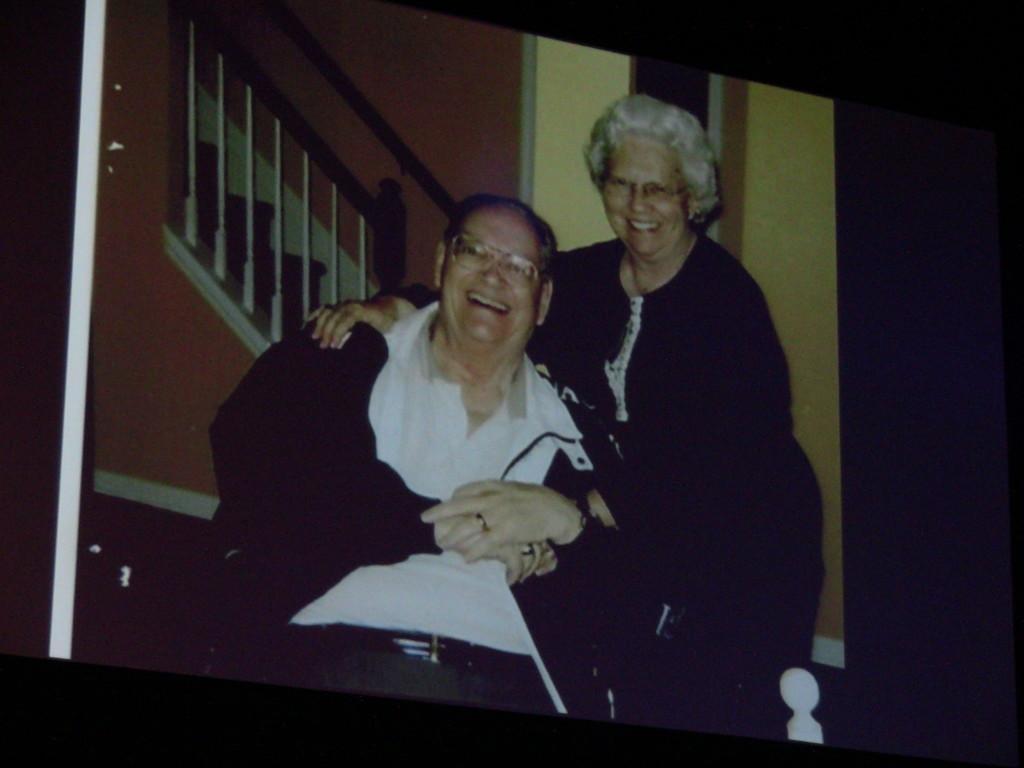Please provide a concise description of this image. In this picture I can see an image in front, where I can see a man and a woman smiling and behind them I can see the steps and the wall. 